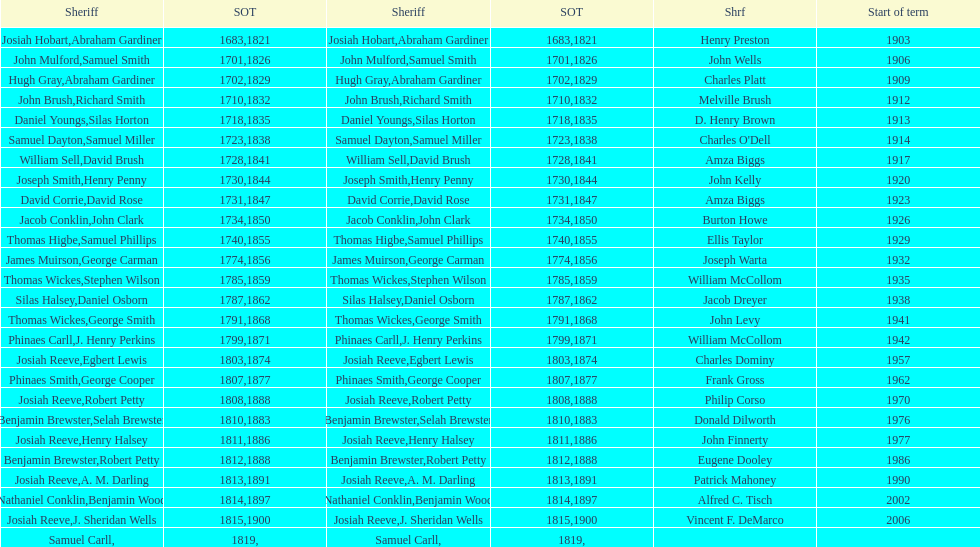How sheriffs has suffolk county had in total? 76. 